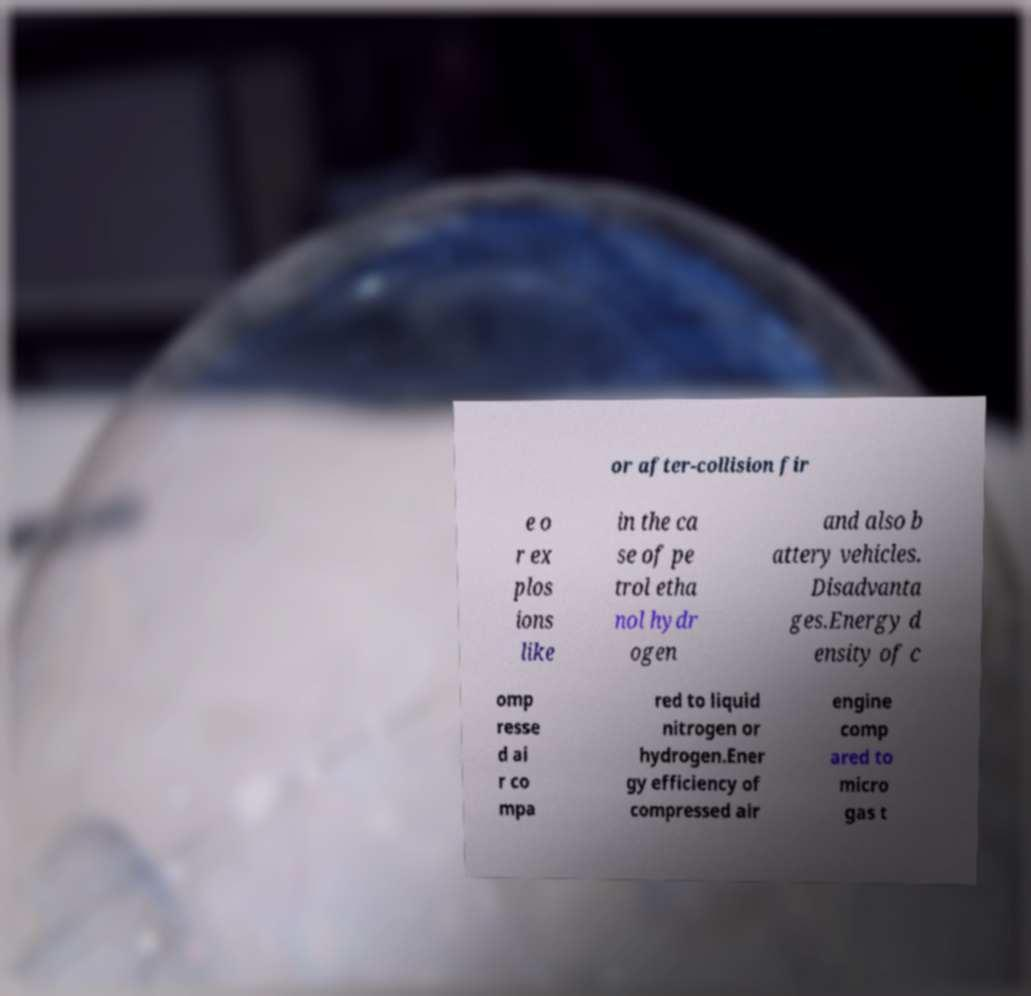For documentation purposes, I need the text within this image transcribed. Could you provide that? or after-collision fir e o r ex plos ions like in the ca se of pe trol etha nol hydr ogen and also b attery vehicles. Disadvanta ges.Energy d ensity of c omp resse d ai r co mpa red to liquid nitrogen or hydrogen.Ener gy efficiency of compressed air engine comp ared to micro gas t 